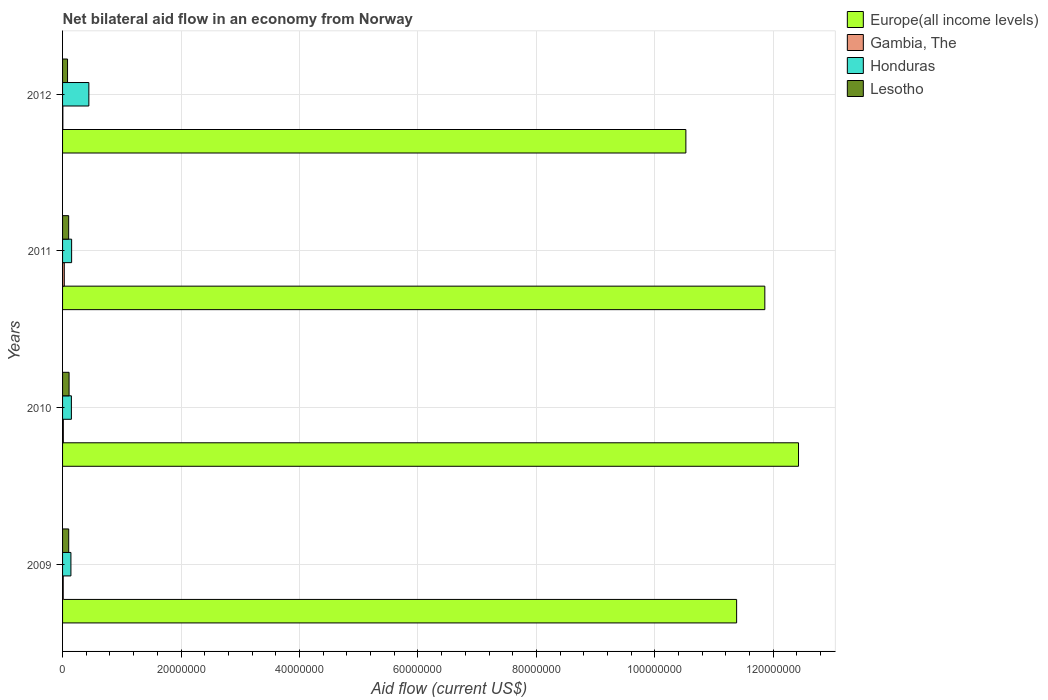How many different coloured bars are there?
Your answer should be compact. 4. Are the number of bars per tick equal to the number of legend labels?
Your response must be concise. Yes. Are the number of bars on each tick of the Y-axis equal?
Your answer should be very brief. Yes. How many bars are there on the 3rd tick from the top?
Ensure brevity in your answer.  4. What is the label of the 4th group of bars from the top?
Keep it short and to the point. 2009. In how many cases, is the number of bars for a given year not equal to the number of legend labels?
Offer a terse response. 0. What is the net bilateral aid flow in Gambia, The in 2009?
Provide a succinct answer. 1.10e+05. Across all years, what is the maximum net bilateral aid flow in Europe(all income levels)?
Ensure brevity in your answer.  1.24e+08. Across all years, what is the minimum net bilateral aid flow in Lesotho?
Ensure brevity in your answer.  8.40e+05. In which year was the net bilateral aid flow in Lesotho maximum?
Provide a short and direct response. 2010. In which year was the net bilateral aid flow in Honduras minimum?
Your response must be concise. 2009. What is the total net bilateral aid flow in Gambia, The in the graph?
Keep it short and to the point. 5.80e+05. What is the difference between the net bilateral aid flow in Honduras in 2010 and the net bilateral aid flow in Gambia, The in 2012?
Offer a terse response. 1.44e+06. What is the average net bilateral aid flow in Lesotho per year?
Offer a very short reply. 1.00e+06. In the year 2010, what is the difference between the net bilateral aid flow in Honduras and net bilateral aid flow in Lesotho?
Provide a short and direct response. 3.90e+05. Is the difference between the net bilateral aid flow in Honduras in 2010 and 2011 greater than the difference between the net bilateral aid flow in Lesotho in 2010 and 2011?
Provide a succinct answer. No. What is the difference between the highest and the second highest net bilateral aid flow in Honduras?
Give a very brief answer. 2.91e+06. What is the difference between the highest and the lowest net bilateral aid flow in Gambia, The?
Provide a succinct answer. 2.40e+05. Is it the case that in every year, the sum of the net bilateral aid flow in Europe(all income levels) and net bilateral aid flow in Gambia, The is greater than the sum of net bilateral aid flow in Lesotho and net bilateral aid flow in Honduras?
Your answer should be compact. Yes. What does the 2nd bar from the top in 2012 represents?
Give a very brief answer. Honduras. What does the 1st bar from the bottom in 2012 represents?
Your answer should be very brief. Europe(all income levels). Is it the case that in every year, the sum of the net bilateral aid flow in Honduras and net bilateral aid flow in Lesotho is greater than the net bilateral aid flow in Gambia, The?
Give a very brief answer. Yes. How many legend labels are there?
Ensure brevity in your answer.  4. How are the legend labels stacked?
Your answer should be compact. Vertical. What is the title of the graph?
Provide a succinct answer. Net bilateral aid flow in an economy from Norway. What is the label or title of the Y-axis?
Your answer should be very brief. Years. What is the Aid flow (current US$) of Europe(all income levels) in 2009?
Give a very brief answer. 1.14e+08. What is the Aid flow (current US$) in Honduras in 2009?
Provide a short and direct response. 1.41e+06. What is the Aid flow (current US$) of Lesotho in 2009?
Your answer should be compact. 1.04e+06. What is the Aid flow (current US$) in Europe(all income levels) in 2010?
Your answer should be compact. 1.24e+08. What is the Aid flow (current US$) of Gambia, The in 2010?
Offer a very short reply. 1.30e+05. What is the Aid flow (current US$) in Honduras in 2010?
Provide a succinct answer. 1.49e+06. What is the Aid flow (current US$) of Lesotho in 2010?
Offer a terse response. 1.10e+06. What is the Aid flow (current US$) in Europe(all income levels) in 2011?
Your answer should be compact. 1.19e+08. What is the Aid flow (current US$) in Honduras in 2011?
Give a very brief answer. 1.53e+06. What is the Aid flow (current US$) in Lesotho in 2011?
Your answer should be compact. 1.03e+06. What is the Aid flow (current US$) in Europe(all income levels) in 2012?
Provide a succinct answer. 1.05e+08. What is the Aid flow (current US$) in Honduras in 2012?
Your answer should be very brief. 4.44e+06. What is the Aid flow (current US$) in Lesotho in 2012?
Provide a short and direct response. 8.40e+05. Across all years, what is the maximum Aid flow (current US$) in Europe(all income levels)?
Keep it short and to the point. 1.24e+08. Across all years, what is the maximum Aid flow (current US$) in Honduras?
Provide a short and direct response. 4.44e+06. Across all years, what is the maximum Aid flow (current US$) of Lesotho?
Your answer should be compact. 1.10e+06. Across all years, what is the minimum Aid flow (current US$) of Europe(all income levels)?
Provide a short and direct response. 1.05e+08. Across all years, what is the minimum Aid flow (current US$) in Honduras?
Your answer should be very brief. 1.41e+06. Across all years, what is the minimum Aid flow (current US$) in Lesotho?
Give a very brief answer. 8.40e+05. What is the total Aid flow (current US$) of Europe(all income levels) in the graph?
Provide a succinct answer. 4.62e+08. What is the total Aid flow (current US$) of Gambia, The in the graph?
Give a very brief answer. 5.80e+05. What is the total Aid flow (current US$) of Honduras in the graph?
Provide a short and direct response. 8.87e+06. What is the total Aid flow (current US$) in Lesotho in the graph?
Keep it short and to the point. 4.01e+06. What is the difference between the Aid flow (current US$) of Europe(all income levels) in 2009 and that in 2010?
Offer a terse response. -1.04e+07. What is the difference between the Aid flow (current US$) of Honduras in 2009 and that in 2010?
Make the answer very short. -8.00e+04. What is the difference between the Aid flow (current US$) of Lesotho in 2009 and that in 2010?
Provide a short and direct response. -6.00e+04. What is the difference between the Aid flow (current US$) in Europe(all income levels) in 2009 and that in 2011?
Your answer should be compact. -4.76e+06. What is the difference between the Aid flow (current US$) in Honduras in 2009 and that in 2011?
Offer a terse response. -1.20e+05. What is the difference between the Aid flow (current US$) in Lesotho in 2009 and that in 2011?
Provide a succinct answer. 10000. What is the difference between the Aid flow (current US$) in Europe(all income levels) in 2009 and that in 2012?
Offer a very short reply. 8.57e+06. What is the difference between the Aid flow (current US$) in Gambia, The in 2009 and that in 2012?
Provide a short and direct response. 6.00e+04. What is the difference between the Aid flow (current US$) of Honduras in 2009 and that in 2012?
Provide a short and direct response. -3.03e+06. What is the difference between the Aid flow (current US$) in Lesotho in 2009 and that in 2012?
Give a very brief answer. 2.00e+05. What is the difference between the Aid flow (current US$) of Europe(all income levels) in 2010 and that in 2011?
Make the answer very short. 5.69e+06. What is the difference between the Aid flow (current US$) of Gambia, The in 2010 and that in 2011?
Ensure brevity in your answer.  -1.60e+05. What is the difference between the Aid flow (current US$) in Honduras in 2010 and that in 2011?
Your answer should be very brief. -4.00e+04. What is the difference between the Aid flow (current US$) in Lesotho in 2010 and that in 2011?
Provide a succinct answer. 7.00e+04. What is the difference between the Aid flow (current US$) in Europe(all income levels) in 2010 and that in 2012?
Provide a short and direct response. 1.90e+07. What is the difference between the Aid flow (current US$) in Gambia, The in 2010 and that in 2012?
Offer a terse response. 8.00e+04. What is the difference between the Aid flow (current US$) in Honduras in 2010 and that in 2012?
Provide a short and direct response. -2.95e+06. What is the difference between the Aid flow (current US$) of Lesotho in 2010 and that in 2012?
Your response must be concise. 2.60e+05. What is the difference between the Aid flow (current US$) in Europe(all income levels) in 2011 and that in 2012?
Your response must be concise. 1.33e+07. What is the difference between the Aid flow (current US$) in Gambia, The in 2011 and that in 2012?
Your answer should be compact. 2.40e+05. What is the difference between the Aid flow (current US$) in Honduras in 2011 and that in 2012?
Provide a short and direct response. -2.91e+06. What is the difference between the Aid flow (current US$) in Europe(all income levels) in 2009 and the Aid flow (current US$) in Gambia, The in 2010?
Ensure brevity in your answer.  1.14e+08. What is the difference between the Aid flow (current US$) in Europe(all income levels) in 2009 and the Aid flow (current US$) in Honduras in 2010?
Your response must be concise. 1.12e+08. What is the difference between the Aid flow (current US$) of Europe(all income levels) in 2009 and the Aid flow (current US$) of Lesotho in 2010?
Offer a terse response. 1.13e+08. What is the difference between the Aid flow (current US$) of Gambia, The in 2009 and the Aid flow (current US$) of Honduras in 2010?
Provide a short and direct response. -1.38e+06. What is the difference between the Aid flow (current US$) in Gambia, The in 2009 and the Aid flow (current US$) in Lesotho in 2010?
Provide a succinct answer. -9.90e+05. What is the difference between the Aid flow (current US$) of Honduras in 2009 and the Aid flow (current US$) of Lesotho in 2010?
Provide a succinct answer. 3.10e+05. What is the difference between the Aid flow (current US$) in Europe(all income levels) in 2009 and the Aid flow (current US$) in Gambia, The in 2011?
Your answer should be compact. 1.14e+08. What is the difference between the Aid flow (current US$) of Europe(all income levels) in 2009 and the Aid flow (current US$) of Honduras in 2011?
Provide a short and direct response. 1.12e+08. What is the difference between the Aid flow (current US$) of Europe(all income levels) in 2009 and the Aid flow (current US$) of Lesotho in 2011?
Your answer should be compact. 1.13e+08. What is the difference between the Aid flow (current US$) in Gambia, The in 2009 and the Aid flow (current US$) in Honduras in 2011?
Provide a short and direct response. -1.42e+06. What is the difference between the Aid flow (current US$) of Gambia, The in 2009 and the Aid flow (current US$) of Lesotho in 2011?
Your answer should be very brief. -9.20e+05. What is the difference between the Aid flow (current US$) in Europe(all income levels) in 2009 and the Aid flow (current US$) in Gambia, The in 2012?
Provide a short and direct response. 1.14e+08. What is the difference between the Aid flow (current US$) of Europe(all income levels) in 2009 and the Aid flow (current US$) of Honduras in 2012?
Give a very brief answer. 1.09e+08. What is the difference between the Aid flow (current US$) of Europe(all income levels) in 2009 and the Aid flow (current US$) of Lesotho in 2012?
Keep it short and to the point. 1.13e+08. What is the difference between the Aid flow (current US$) of Gambia, The in 2009 and the Aid flow (current US$) of Honduras in 2012?
Your answer should be very brief. -4.33e+06. What is the difference between the Aid flow (current US$) of Gambia, The in 2009 and the Aid flow (current US$) of Lesotho in 2012?
Provide a succinct answer. -7.30e+05. What is the difference between the Aid flow (current US$) in Honduras in 2009 and the Aid flow (current US$) in Lesotho in 2012?
Offer a very short reply. 5.70e+05. What is the difference between the Aid flow (current US$) in Europe(all income levels) in 2010 and the Aid flow (current US$) in Gambia, The in 2011?
Offer a terse response. 1.24e+08. What is the difference between the Aid flow (current US$) of Europe(all income levels) in 2010 and the Aid flow (current US$) of Honduras in 2011?
Ensure brevity in your answer.  1.23e+08. What is the difference between the Aid flow (current US$) of Europe(all income levels) in 2010 and the Aid flow (current US$) of Lesotho in 2011?
Ensure brevity in your answer.  1.23e+08. What is the difference between the Aid flow (current US$) in Gambia, The in 2010 and the Aid flow (current US$) in Honduras in 2011?
Your answer should be compact. -1.40e+06. What is the difference between the Aid flow (current US$) of Gambia, The in 2010 and the Aid flow (current US$) of Lesotho in 2011?
Make the answer very short. -9.00e+05. What is the difference between the Aid flow (current US$) in Europe(all income levels) in 2010 and the Aid flow (current US$) in Gambia, The in 2012?
Provide a succinct answer. 1.24e+08. What is the difference between the Aid flow (current US$) of Europe(all income levels) in 2010 and the Aid flow (current US$) of Honduras in 2012?
Your response must be concise. 1.20e+08. What is the difference between the Aid flow (current US$) of Europe(all income levels) in 2010 and the Aid flow (current US$) of Lesotho in 2012?
Provide a short and direct response. 1.23e+08. What is the difference between the Aid flow (current US$) in Gambia, The in 2010 and the Aid flow (current US$) in Honduras in 2012?
Your response must be concise. -4.31e+06. What is the difference between the Aid flow (current US$) in Gambia, The in 2010 and the Aid flow (current US$) in Lesotho in 2012?
Ensure brevity in your answer.  -7.10e+05. What is the difference between the Aid flow (current US$) of Honduras in 2010 and the Aid flow (current US$) of Lesotho in 2012?
Provide a short and direct response. 6.50e+05. What is the difference between the Aid flow (current US$) in Europe(all income levels) in 2011 and the Aid flow (current US$) in Gambia, The in 2012?
Ensure brevity in your answer.  1.19e+08. What is the difference between the Aid flow (current US$) of Europe(all income levels) in 2011 and the Aid flow (current US$) of Honduras in 2012?
Provide a succinct answer. 1.14e+08. What is the difference between the Aid flow (current US$) in Europe(all income levels) in 2011 and the Aid flow (current US$) in Lesotho in 2012?
Provide a succinct answer. 1.18e+08. What is the difference between the Aid flow (current US$) of Gambia, The in 2011 and the Aid flow (current US$) of Honduras in 2012?
Provide a succinct answer. -4.15e+06. What is the difference between the Aid flow (current US$) of Gambia, The in 2011 and the Aid flow (current US$) of Lesotho in 2012?
Your answer should be very brief. -5.50e+05. What is the difference between the Aid flow (current US$) of Honduras in 2011 and the Aid flow (current US$) of Lesotho in 2012?
Make the answer very short. 6.90e+05. What is the average Aid flow (current US$) of Europe(all income levels) per year?
Give a very brief answer. 1.15e+08. What is the average Aid flow (current US$) in Gambia, The per year?
Make the answer very short. 1.45e+05. What is the average Aid flow (current US$) in Honduras per year?
Keep it short and to the point. 2.22e+06. What is the average Aid flow (current US$) in Lesotho per year?
Provide a succinct answer. 1.00e+06. In the year 2009, what is the difference between the Aid flow (current US$) in Europe(all income levels) and Aid flow (current US$) in Gambia, The?
Make the answer very short. 1.14e+08. In the year 2009, what is the difference between the Aid flow (current US$) in Europe(all income levels) and Aid flow (current US$) in Honduras?
Your answer should be very brief. 1.12e+08. In the year 2009, what is the difference between the Aid flow (current US$) in Europe(all income levels) and Aid flow (current US$) in Lesotho?
Provide a succinct answer. 1.13e+08. In the year 2009, what is the difference between the Aid flow (current US$) of Gambia, The and Aid flow (current US$) of Honduras?
Provide a short and direct response. -1.30e+06. In the year 2009, what is the difference between the Aid flow (current US$) in Gambia, The and Aid flow (current US$) in Lesotho?
Your response must be concise. -9.30e+05. In the year 2010, what is the difference between the Aid flow (current US$) in Europe(all income levels) and Aid flow (current US$) in Gambia, The?
Offer a very short reply. 1.24e+08. In the year 2010, what is the difference between the Aid flow (current US$) in Europe(all income levels) and Aid flow (current US$) in Honduras?
Your response must be concise. 1.23e+08. In the year 2010, what is the difference between the Aid flow (current US$) in Europe(all income levels) and Aid flow (current US$) in Lesotho?
Provide a short and direct response. 1.23e+08. In the year 2010, what is the difference between the Aid flow (current US$) in Gambia, The and Aid flow (current US$) in Honduras?
Your answer should be compact. -1.36e+06. In the year 2010, what is the difference between the Aid flow (current US$) in Gambia, The and Aid flow (current US$) in Lesotho?
Ensure brevity in your answer.  -9.70e+05. In the year 2011, what is the difference between the Aid flow (current US$) in Europe(all income levels) and Aid flow (current US$) in Gambia, The?
Your response must be concise. 1.18e+08. In the year 2011, what is the difference between the Aid flow (current US$) of Europe(all income levels) and Aid flow (current US$) of Honduras?
Give a very brief answer. 1.17e+08. In the year 2011, what is the difference between the Aid flow (current US$) in Europe(all income levels) and Aid flow (current US$) in Lesotho?
Your response must be concise. 1.18e+08. In the year 2011, what is the difference between the Aid flow (current US$) of Gambia, The and Aid flow (current US$) of Honduras?
Provide a succinct answer. -1.24e+06. In the year 2011, what is the difference between the Aid flow (current US$) of Gambia, The and Aid flow (current US$) of Lesotho?
Provide a succinct answer. -7.40e+05. In the year 2011, what is the difference between the Aid flow (current US$) of Honduras and Aid flow (current US$) of Lesotho?
Offer a very short reply. 5.00e+05. In the year 2012, what is the difference between the Aid flow (current US$) in Europe(all income levels) and Aid flow (current US$) in Gambia, The?
Your answer should be very brief. 1.05e+08. In the year 2012, what is the difference between the Aid flow (current US$) in Europe(all income levels) and Aid flow (current US$) in Honduras?
Your answer should be very brief. 1.01e+08. In the year 2012, what is the difference between the Aid flow (current US$) of Europe(all income levels) and Aid flow (current US$) of Lesotho?
Make the answer very short. 1.04e+08. In the year 2012, what is the difference between the Aid flow (current US$) in Gambia, The and Aid flow (current US$) in Honduras?
Your answer should be very brief. -4.39e+06. In the year 2012, what is the difference between the Aid flow (current US$) of Gambia, The and Aid flow (current US$) of Lesotho?
Make the answer very short. -7.90e+05. In the year 2012, what is the difference between the Aid flow (current US$) of Honduras and Aid flow (current US$) of Lesotho?
Offer a terse response. 3.60e+06. What is the ratio of the Aid flow (current US$) of Europe(all income levels) in 2009 to that in 2010?
Provide a succinct answer. 0.92. What is the ratio of the Aid flow (current US$) of Gambia, The in 2009 to that in 2010?
Provide a short and direct response. 0.85. What is the ratio of the Aid flow (current US$) of Honduras in 2009 to that in 2010?
Ensure brevity in your answer.  0.95. What is the ratio of the Aid flow (current US$) in Lesotho in 2009 to that in 2010?
Provide a short and direct response. 0.95. What is the ratio of the Aid flow (current US$) in Europe(all income levels) in 2009 to that in 2011?
Make the answer very short. 0.96. What is the ratio of the Aid flow (current US$) of Gambia, The in 2009 to that in 2011?
Provide a short and direct response. 0.38. What is the ratio of the Aid flow (current US$) of Honduras in 2009 to that in 2011?
Your answer should be very brief. 0.92. What is the ratio of the Aid flow (current US$) in Lesotho in 2009 to that in 2011?
Provide a short and direct response. 1.01. What is the ratio of the Aid flow (current US$) in Europe(all income levels) in 2009 to that in 2012?
Your response must be concise. 1.08. What is the ratio of the Aid flow (current US$) of Gambia, The in 2009 to that in 2012?
Provide a short and direct response. 2.2. What is the ratio of the Aid flow (current US$) in Honduras in 2009 to that in 2012?
Ensure brevity in your answer.  0.32. What is the ratio of the Aid flow (current US$) in Lesotho in 2009 to that in 2012?
Offer a terse response. 1.24. What is the ratio of the Aid flow (current US$) in Europe(all income levels) in 2010 to that in 2011?
Your answer should be very brief. 1.05. What is the ratio of the Aid flow (current US$) in Gambia, The in 2010 to that in 2011?
Offer a very short reply. 0.45. What is the ratio of the Aid flow (current US$) of Honduras in 2010 to that in 2011?
Offer a terse response. 0.97. What is the ratio of the Aid flow (current US$) in Lesotho in 2010 to that in 2011?
Offer a very short reply. 1.07. What is the ratio of the Aid flow (current US$) in Europe(all income levels) in 2010 to that in 2012?
Your answer should be compact. 1.18. What is the ratio of the Aid flow (current US$) of Gambia, The in 2010 to that in 2012?
Provide a short and direct response. 2.6. What is the ratio of the Aid flow (current US$) of Honduras in 2010 to that in 2012?
Give a very brief answer. 0.34. What is the ratio of the Aid flow (current US$) in Lesotho in 2010 to that in 2012?
Provide a short and direct response. 1.31. What is the ratio of the Aid flow (current US$) of Europe(all income levels) in 2011 to that in 2012?
Your answer should be very brief. 1.13. What is the ratio of the Aid flow (current US$) in Gambia, The in 2011 to that in 2012?
Give a very brief answer. 5.8. What is the ratio of the Aid flow (current US$) of Honduras in 2011 to that in 2012?
Your answer should be compact. 0.34. What is the ratio of the Aid flow (current US$) in Lesotho in 2011 to that in 2012?
Offer a terse response. 1.23. What is the difference between the highest and the second highest Aid flow (current US$) of Europe(all income levels)?
Provide a succinct answer. 5.69e+06. What is the difference between the highest and the second highest Aid flow (current US$) in Honduras?
Your response must be concise. 2.91e+06. What is the difference between the highest and the second highest Aid flow (current US$) of Lesotho?
Provide a succinct answer. 6.00e+04. What is the difference between the highest and the lowest Aid flow (current US$) in Europe(all income levels)?
Your response must be concise. 1.90e+07. What is the difference between the highest and the lowest Aid flow (current US$) in Gambia, The?
Give a very brief answer. 2.40e+05. What is the difference between the highest and the lowest Aid flow (current US$) in Honduras?
Make the answer very short. 3.03e+06. 